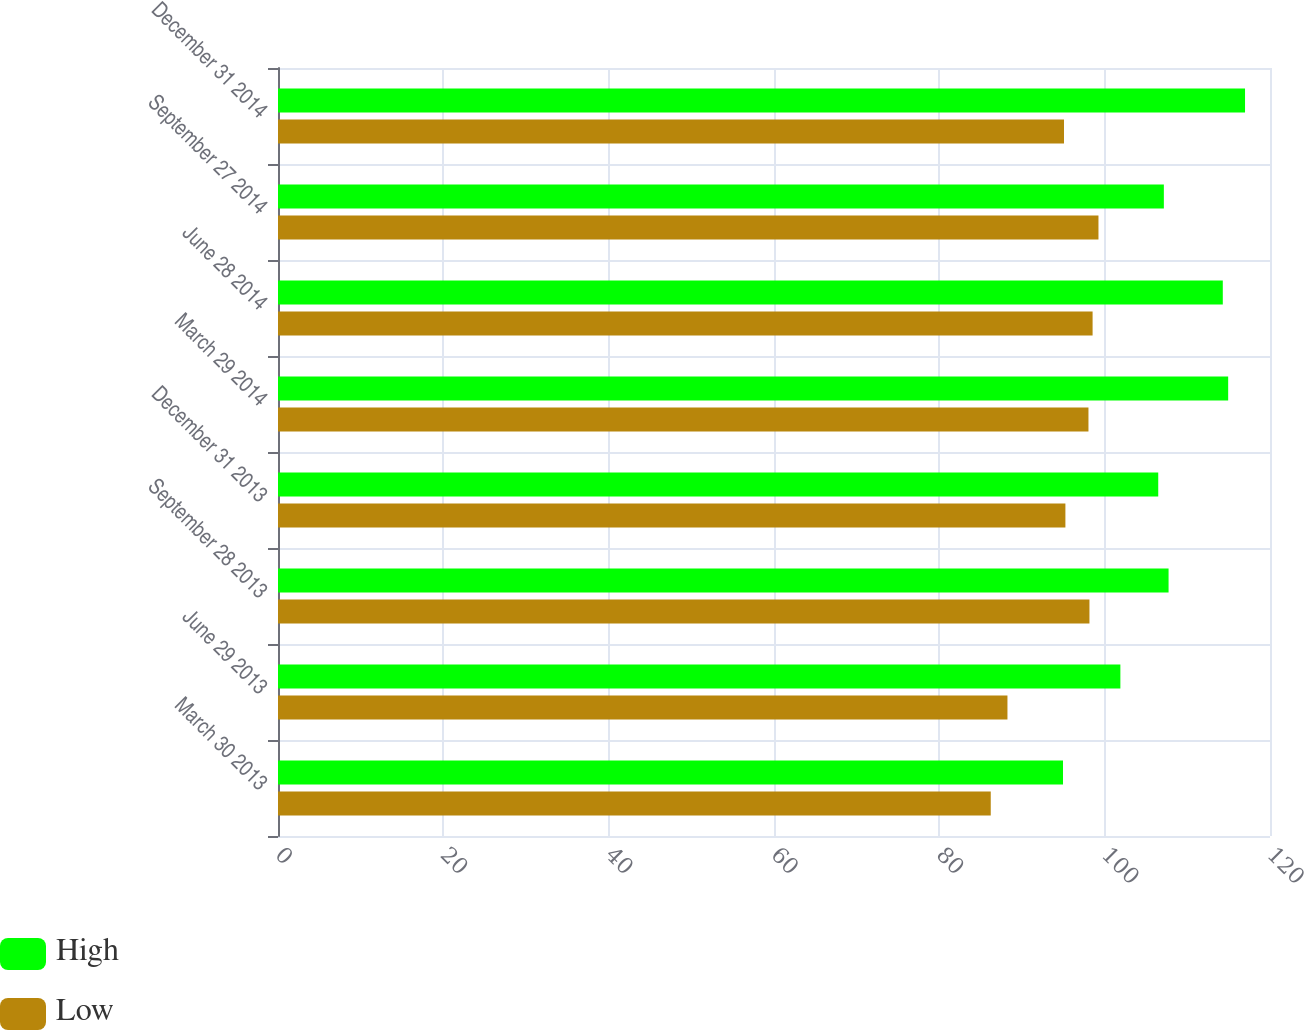Convert chart. <chart><loc_0><loc_0><loc_500><loc_500><stacked_bar_chart><ecel><fcel>March 30 2013<fcel>June 29 2013<fcel>September 28 2013<fcel>December 31 2013<fcel>March 29 2014<fcel>June 28 2014<fcel>September 27 2014<fcel>December 31 2014<nl><fcel>High<fcel>94.96<fcel>101.9<fcel>107.73<fcel>106.48<fcel>114.94<fcel>114.29<fcel>107.16<fcel>116.98<nl><fcel>Low<fcel>86.22<fcel>88.24<fcel>98.16<fcel>95.25<fcel>98.04<fcel>98.54<fcel>99.25<fcel>95.08<nl></chart> 